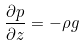<formula> <loc_0><loc_0><loc_500><loc_500>\frac { \partial p } { \partial z } = - \rho g</formula> 